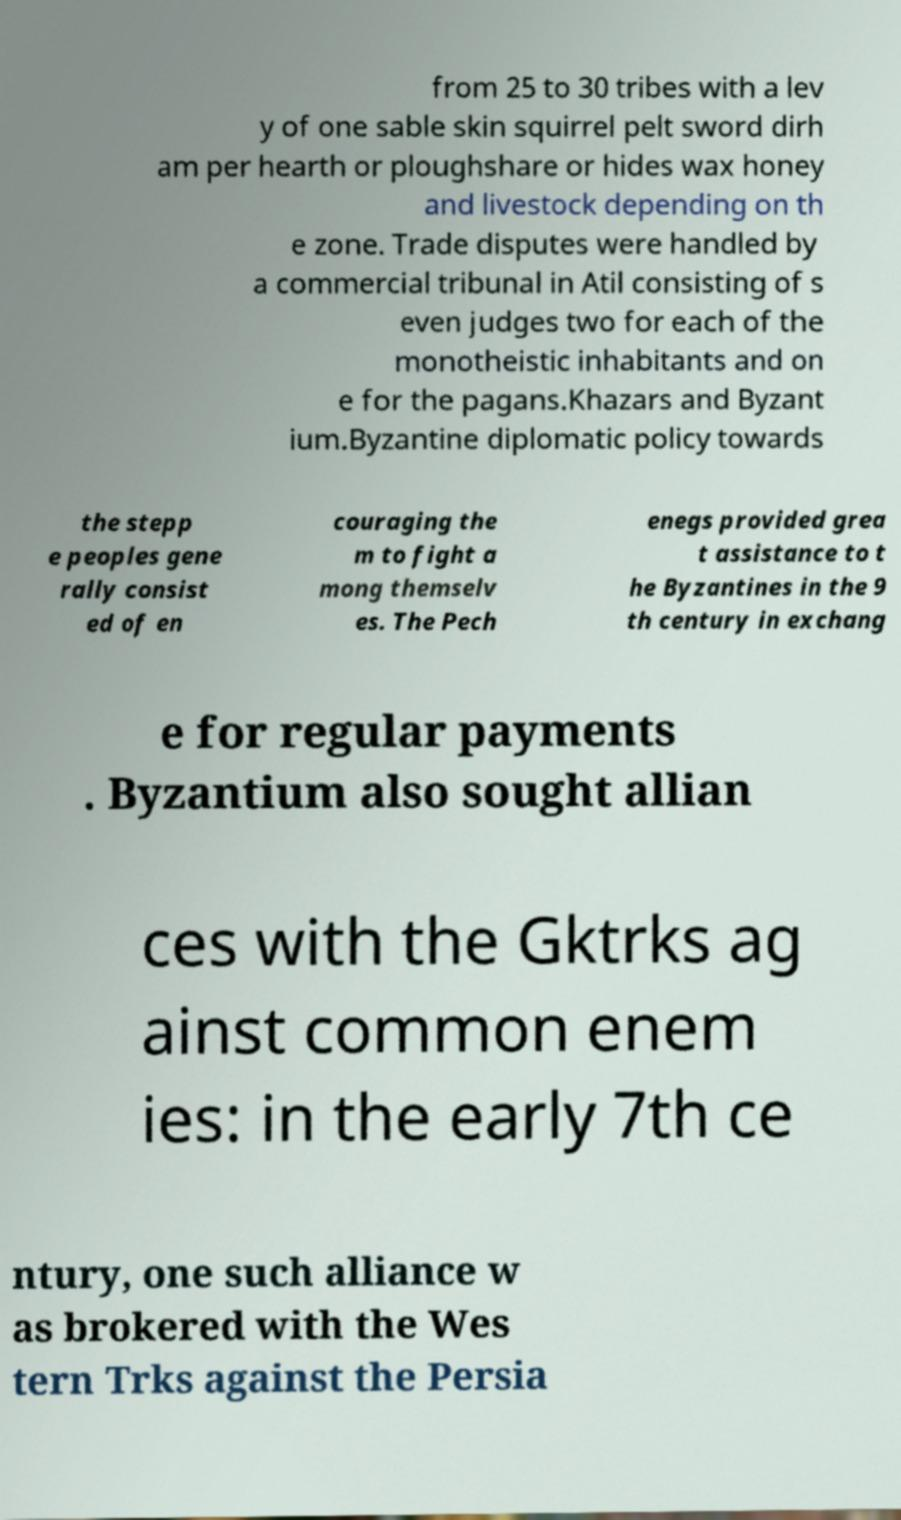Can you read and provide the text displayed in the image?This photo seems to have some interesting text. Can you extract and type it out for me? from 25 to 30 tribes with a lev y of one sable skin squirrel pelt sword dirh am per hearth or ploughshare or hides wax honey and livestock depending on th e zone. Trade disputes were handled by a commercial tribunal in Atil consisting of s even judges two for each of the monotheistic inhabitants and on e for the pagans.Khazars and Byzant ium.Byzantine diplomatic policy towards the stepp e peoples gene rally consist ed of en couraging the m to fight a mong themselv es. The Pech enegs provided grea t assistance to t he Byzantines in the 9 th century in exchang e for regular payments . Byzantium also sought allian ces with the Gktrks ag ainst common enem ies: in the early 7th ce ntury, one such alliance w as brokered with the Wes tern Trks against the Persia 